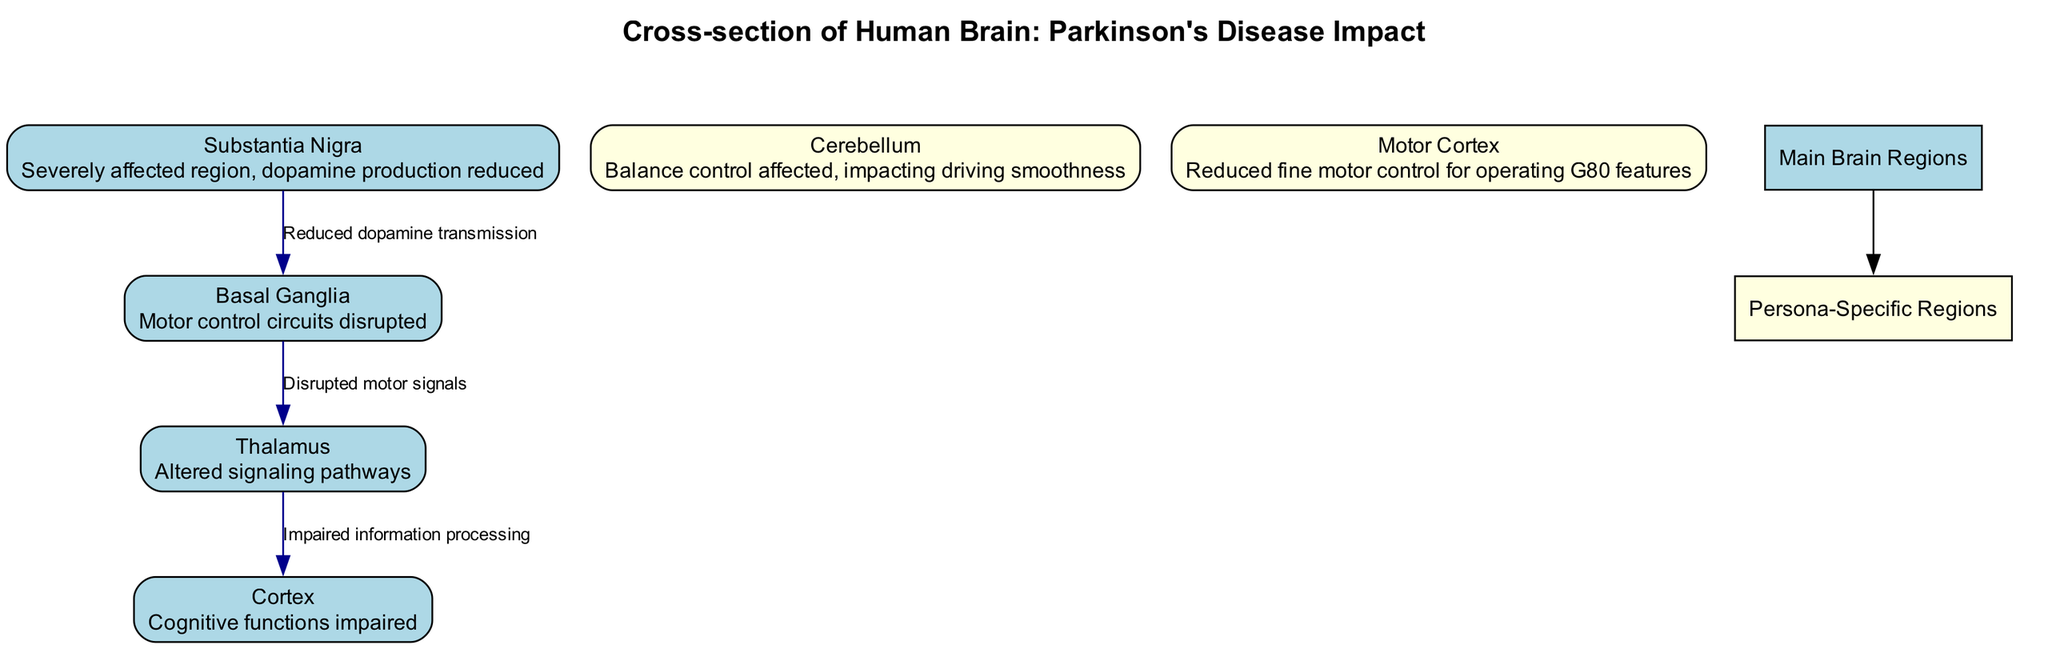What is the most affected region in Parkinson's disease? The diagram labels the Substantia Nigra as the "Severely affected region, dopamine production reduced," which indicates that it is the most affected area in the context of Parkinson's disease.
Answer: Substantia Nigra How many main brain regions are highlighted? The diagram lists four main elements: Substantia Nigra, Basal Ganglia, Cortex, and Thalamus. Therefore, by counting these elements, we determine that there are four main brain regions highlighted.
Answer: Four What is the connection between the Basal Ganglia and Thalamus? The diagram indicates that the connection is labeled as "Disrupted motor signals," which details the relationship between these two regions. To find this information, we look at the connections in the diagram specifically.
Answer: Disrupted motor signals Which region is responsible for balance control? The persona-specific element of the Cerebellum mentions "Balance control affected," showing that it is the region responsible for balance. We identify this by checking the description of the specific elements tailored for the persona.
Answer: Cerebellum What impaired function is associated with the Cortex? The description under the Cortex in the diagram states "Cognitive functions impaired." This directly answers the question regarding its role in the context of Parkinson's disease induced changes.
Answer: Cognitive functions impaired How many connections are present in the diagram? By counting the connection entries labeled in the diagram, we note three connections: from Substantia Nigra to Basal Ganglia, from Basal Ganglia to Thalamus, and from Thalamus to Cortex. Thus, the total number of connections is three.
Answer: Three What does the connection from the Thalamus to the Cortex indicate? The diagram specifies that the connection is labeled "Impaired information processing," detailing the nature of the relationship in terms of functionality between these brain regions. We find this by examining the directional arrows and their labels in the connections section.
Answer: Impaired information processing Which specific region affects the smoothness of driving? In the persona-specific section, the description of the Cerebellum states "Balance control affected, impacting driving smoothness." This highlights that the Cerebellum is the specific region that affects driving smoothness.
Answer: Cerebellum What type of control is reduced in the Motor Cortex? The description associated with the Motor Cortex states "Reduced fine motor control for operating G80 features," thus indicating the specific control adversely affected in this situation.
Answer: Reduced fine motor control 